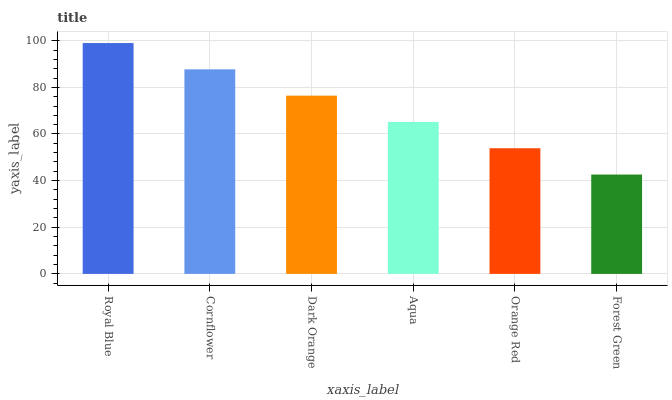Is Forest Green the minimum?
Answer yes or no. Yes. Is Royal Blue the maximum?
Answer yes or no. Yes. Is Cornflower the minimum?
Answer yes or no. No. Is Cornflower the maximum?
Answer yes or no. No. Is Royal Blue greater than Cornflower?
Answer yes or no. Yes. Is Cornflower less than Royal Blue?
Answer yes or no. Yes. Is Cornflower greater than Royal Blue?
Answer yes or no. No. Is Royal Blue less than Cornflower?
Answer yes or no. No. Is Dark Orange the high median?
Answer yes or no. Yes. Is Aqua the low median?
Answer yes or no. Yes. Is Orange Red the high median?
Answer yes or no. No. Is Cornflower the low median?
Answer yes or no. No. 